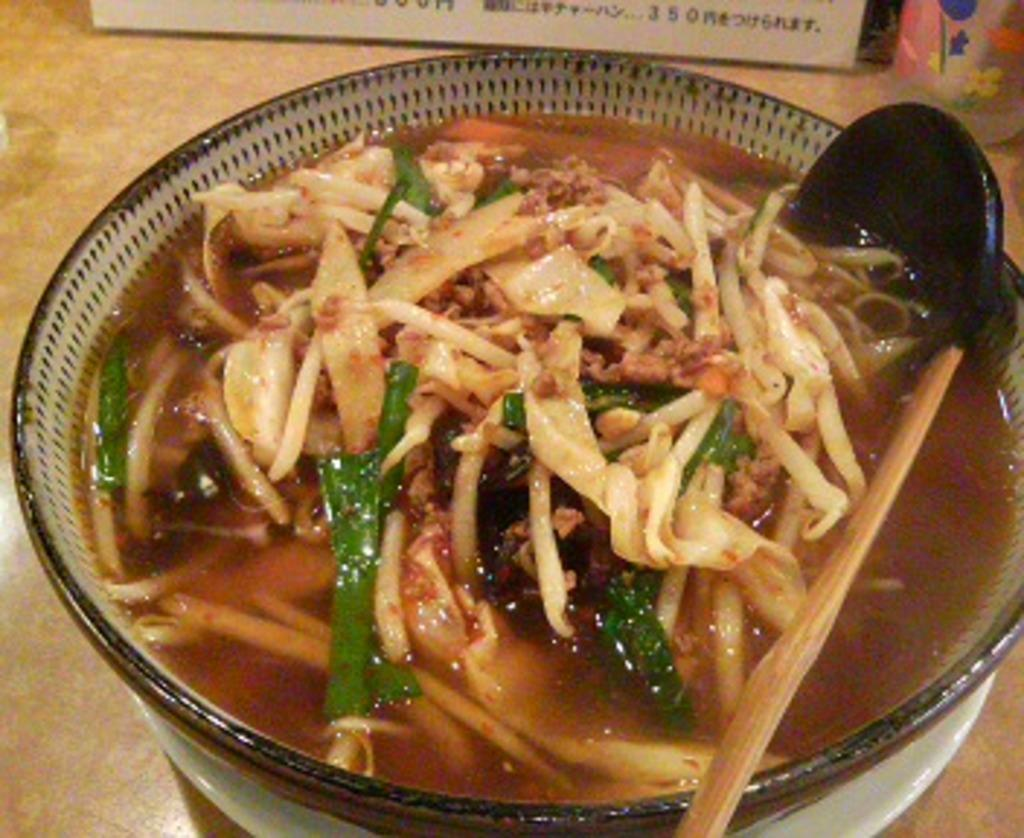What is in the soup that is visible in the image? There are vegetable pieces in a soup. What utensil is visible in the image? There is a spoon in a bowl. What color is the bowl in the image? The bowl is white in color. Where is the bowl located in the image? The bowl is on a table. What other items can be seen on the table in the image? There is a name board and a bottle on the table. What direction is the army marching in the image? There is no army present in the image, so it is not possible to determine the direction in which they might be marching. 